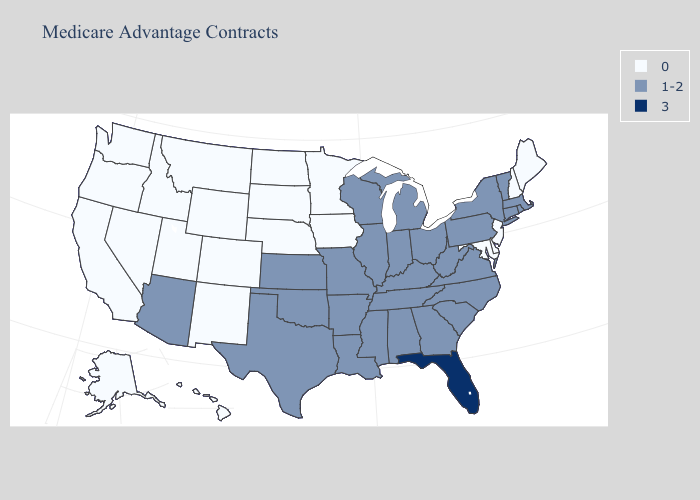Name the states that have a value in the range 3?
Keep it brief. Florida. Name the states that have a value in the range 0?
Write a very short answer. Alaska, California, Colorado, Delaware, Hawaii, Iowa, Idaho, Maryland, Maine, Minnesota, Montana, North Dakota, Nebraska, New Hampshire, New Jersey, New Mexico, Nevada, Oregon, South Dakota, Utah, Washington, Wyoming. Name the states that have a value in the range 1-2?
Give a very brief answer. Alabama, Arkansas, Arizona, Connecticut, Georgia, Illinois, Indiana, Kansas, Kentucky, Louisiana, Massachusetts, Michigan, Missouri, Mississippi, North Carolina, New York, Ohio, Oklahoma, Pennsylvania, Rhode Island, South Carolina, Tennessee, Texas, Virginia, Vermont, Wisconsin, West Virginia. What is the lowest value in states that border Pennsylvania?
Concise answer only. 0. Name the states that have a value in the range 1-2?
Answer briefly. Alabama, Arkansas, Arizona, Connecticut, Georgia, Illinois, Indiana, Kansas, Kentucky, Louisiana, Massachusetts, Michigan, Missouri, Mississippi, North Carolina, New York, Ohio, Oklahoma, Pennsylvania, Rhode Island, South Carolina, Tennessee, Texas, Virginia, Vermont, Wisconsin, West Virginia. Name the states that have a value in the range 1-2?
Be succinct. Alabama, Arkansas, Arizona, Connecticut, Georgia, Illinois, Indiana, Kansas, Kentucky, Louisiana, Massachusetts, Michigan, Missouri, Mississippi, North Carolina, New York, Ohio, Oklahoma, Pennsylvania, Rhode Island, South Carolina, Tennessee, Texas, Virginia, Vermont, Wisconsin, West Virginia. Name the states that have a value in the range 1-2?
Short answer required. Alabama, Arkansas, Arizona, Connecticut, Georgia, Illinois, Indiana, Kansas, Kentucky, Louisiana, Massachusetts, Michigan, Missouri, Mississippi, North Carolina, New York, Ohio, Oklahoma, Pennsylvania, Rhode Island, South Carolina, Tennessee, Texas, Virginia, Vermont, Wisconsin, West Virginia. What is the lowest value in the West?
Answer briefly. 0. Name the states that have a value in the range 1-2?
Answer briefly. Alabama, Arkansas, Arizona, Connecticut, Georgia, Illinois, Indiana, Kansas, Kentucky, Louisiana, Massachusetts, Michigan, Missouri, Mississippi, North Carolina, New York, Ohio, Oklahoma, Pennsylvania, Rhode Island, South Carolina, Tennessee, Texas, Virginia, Vermont, Wisconsin, West Virginia. What is the highest value in states that border Arkansas?
Be succinct. 1-2. Among the states that border Idaho , which have the lowest value?
Short answer required. Montana, Nevada, Oregon, Utah, Washington, Wyoming. Does Rhode Island have the highest value in the Northeast?
Concise answer only. Yes. What is the value of Texas?
Answer briefly. 1-2. Does Delaware have the highest value in the South?
Concise answer only. No. Name the states that have a value in the range 1-2?
Be succinct. Alabama, Arkansas, Arizona, Connecticut, Georgia, Illinois, Indiana, Kansas, Kentucky, Louisiana, Massachusetts, Michigan, Missouri, Mississippi, North Carolina, New York, Ohio, Oklahoma, Pennsylvania, Rhode Island, South Carolina, Tennessee, Texas, Virginia, Vermont, Wisconsin, West Virginia. 